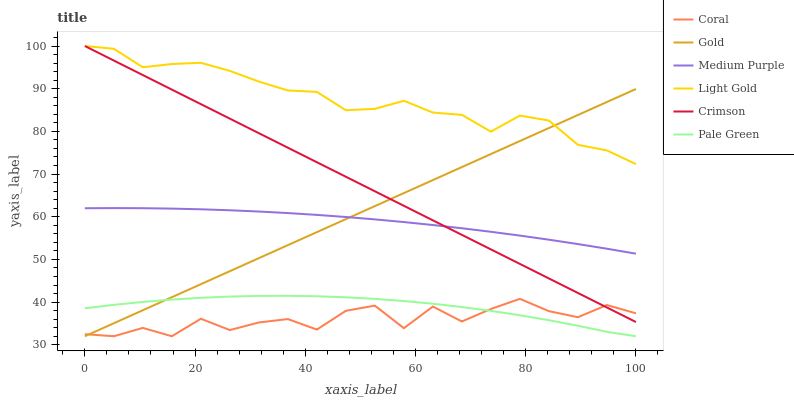Does Coral have the minimum area under the curve?
Answer yes or no. Yes. Does Light Gold have the maximum area under the curve?
Answer yes or no. Yes. Does Medium Purple have the minimum area under the curve?
Answer yes or no. No. Does Medium Purple have the maximum area under the curve?
Answer yes or no. No. Is Crimson the smoothest?
Answer yes or no. Yes. Is Coral the roughest?
Answer yes or no. Yes. Is Medium Purple the smoothest?
Answer yes or no. No. Is Medium Purple the roughest?
Answer yes or no. No. Does Gold have the lowest value?
Answer yes or no. Yes. Does Medium Purple have the lowest value?
Answer yes or no. No. Does Light Gold have the highest value?
Answer yes or no. Yes. Does Medium Purple have the highest value?
Answer yes or no. No. Is Pale Green less than Medium Purple?
Answer yes or no. Yes. Is Medium Purple greater than Pale Green?
Answer yes or no. Yes. Does Coral intersect Pale Green?
Answer yes or no. Yes. Is Coral less than Pale Green?
Answer yes or no. No. Is Coral greater than Pale Green?
Answer yes or no. No. Does Pale Green intersect Medium Purple?
Answer yes or no. No. 